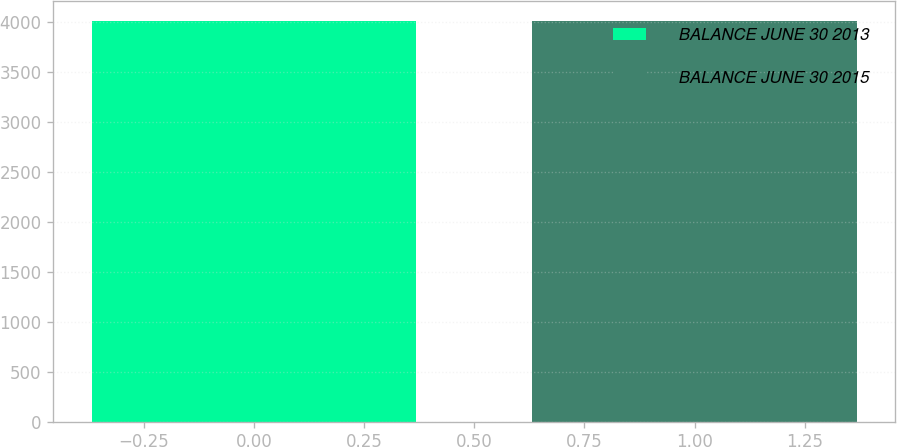<chart> <loc_0><loc_0><loc_500><loc_500><bar_chart><fcel>BALANCE JUNE 30 2013<fcel>BALANCE JUNE 30 2015<nl><fcel>4009<fcel>4009.1<nl></chart> 